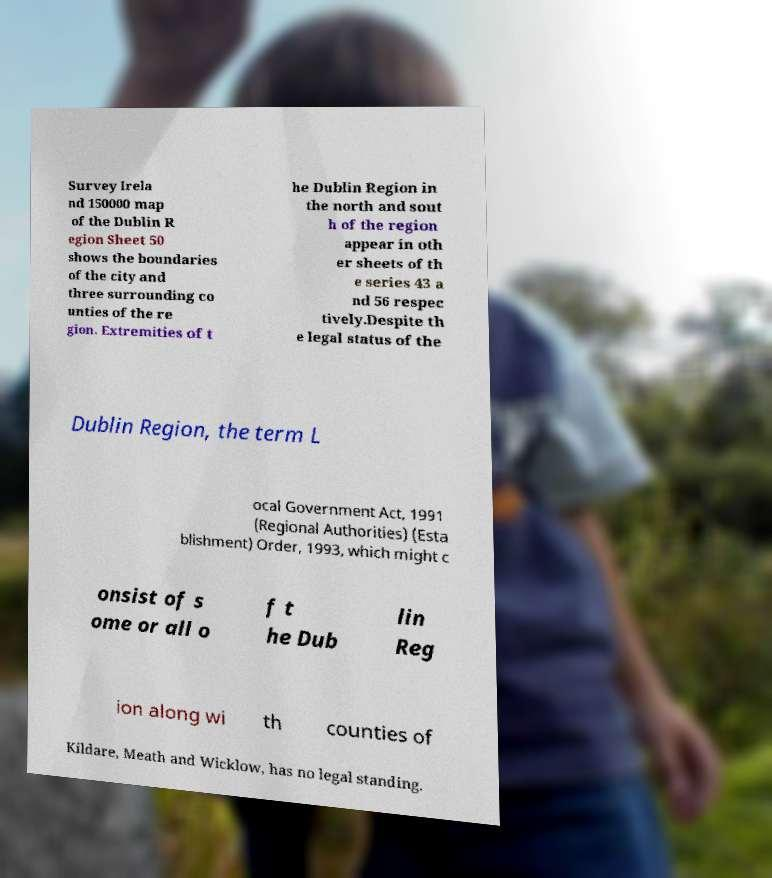Could you extract and type out the text from this image? Survey Irela nd 150000 map of the Dublin R egion Sheet 50 shows the boundaries of the city and three surrounding co unties of the re gion. Extremities of t he Dublin Region in the north and sout h of the region appear in oth er sheets of th e series 43 a nd 56 respec tively.Despite th e legal status of the Dublin Region, the term L ocal Government Act, 1991 (Regional Authorities) (Esta blishment) Order, 1993, which might c onsist of s ome or all o f t he Dub lin Reg ion along wi th counties of Kildare, Meath and Wicklow, has no legal standing. 